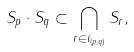<formula> <loc_0><loc_0><loc_500><loc_500>S _ { p } \cdot S _ { q } \subset \bigcap _ { r \in i _ { \left ( p , q \right ) } } S _ { r } ,</formula> 